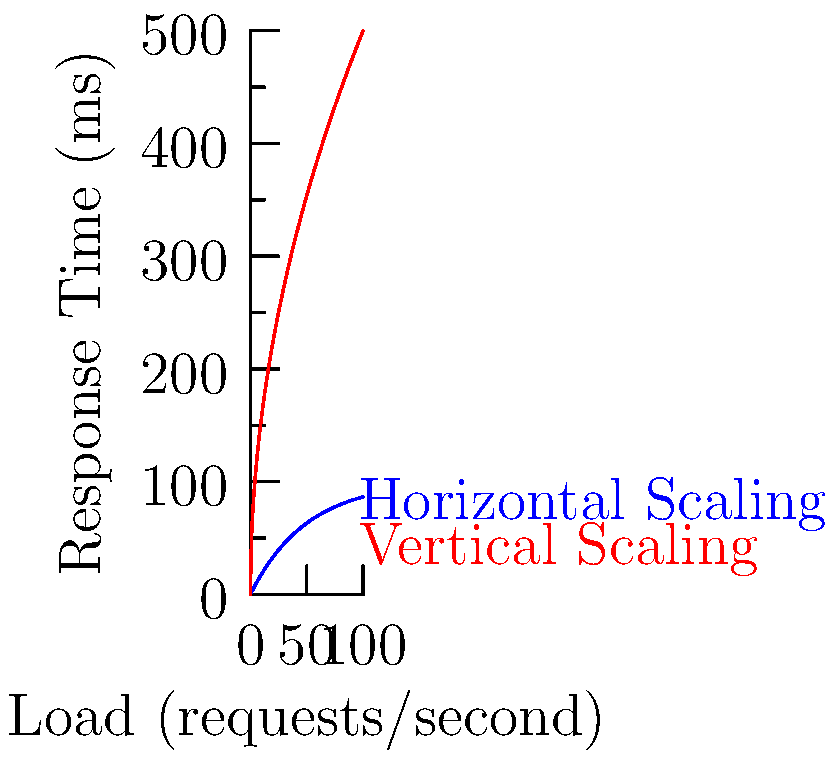The graph shows the response time of a backend system under increasing load for two different scaling strategies. Which scaling strategy performs better as the load increases, and why? To determine which scaling strategy performs better as load increases, we need to analyze the behavior of both curves:

1. Blue curve (Horizontal Scaling):
   - Follows a logarithmic-like growth pattern
   - Response time increases rapidly at first but then levels off
   - Approaches a horizontal asymptote (around 100ms)

2. Red curve (Vertical Scaling):
   - Follows a square root growth pattern
   - Response time increases more slowly at first but continues to grow

3. Comparison:
   - For low loads (< 30 requests/second), vertical scaling performs better
   - As load increases (> 30 requests/second), horizontal scaling outperforms vertical scaling
   - At high loads, horizontal scaling maintains a stable response time, while vertical scaling's response time continues to increase

4. Explanation:
   - Horizontal scaling (adding more servers) distributes the load across multiple machines, allowing for better parallelization and load balancing
   - Vertical scaling (adding more resources to a single server) has limitations due to hardware constraints and diminishing returns on added resources

5. Conclusion:
   Horizontal scaling performs better as load increases because it maintains a more stable response time and can handle higher loads more efficiently than vertical scaling.
Answer: Horizontal scaling performs better at higher loads due to better load distribution and scalability. 